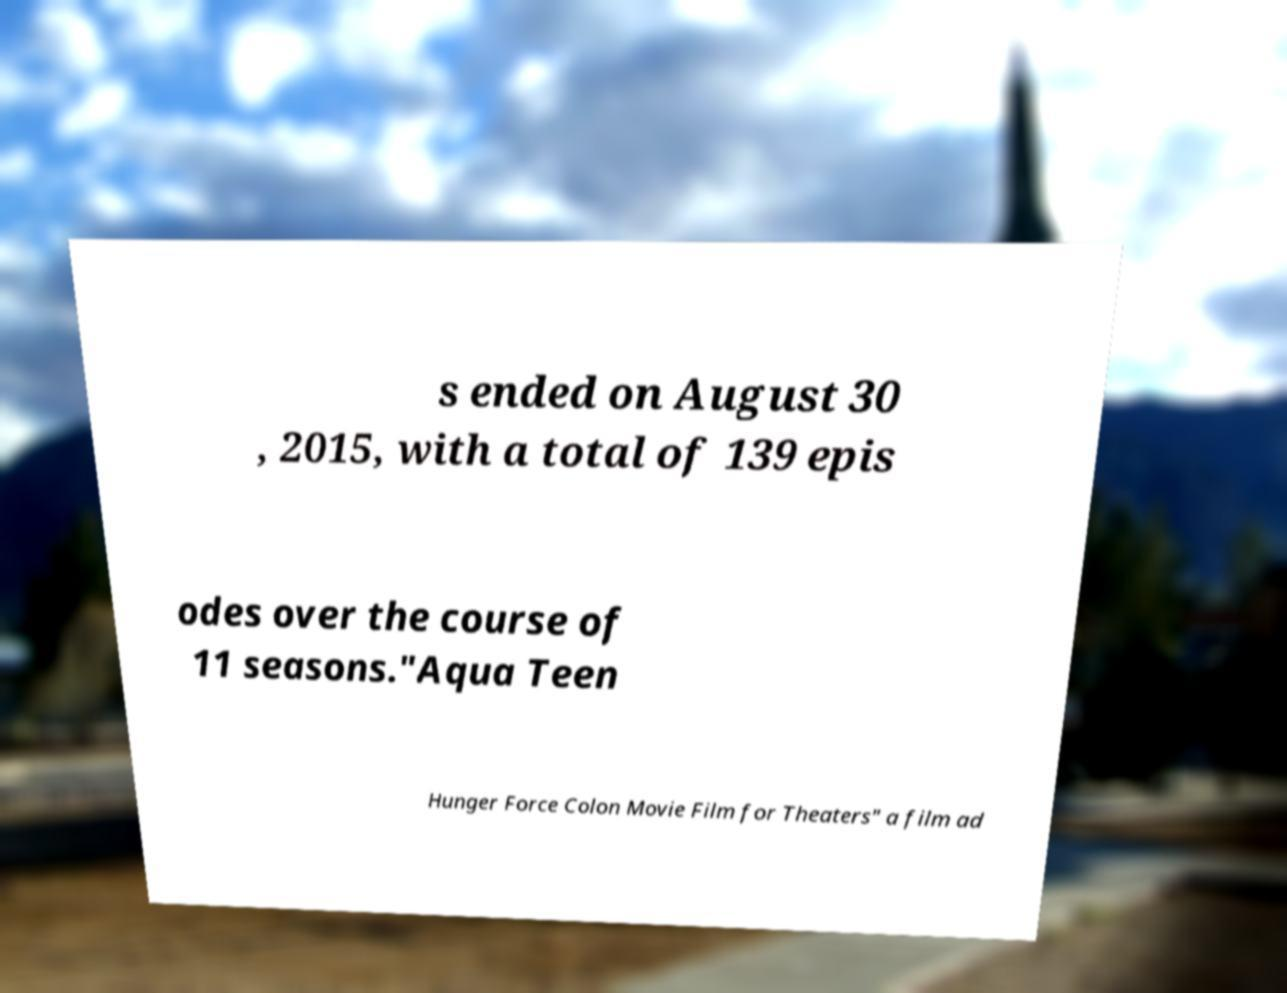I need the written content from this picture converted into text. Can you do that? s ended on August 30 , 2015, with a total of 139 epis odes over the course of 11 seasons."Aqua Teen Hunger Force Colon Movie Film for Theaters" a film ad 